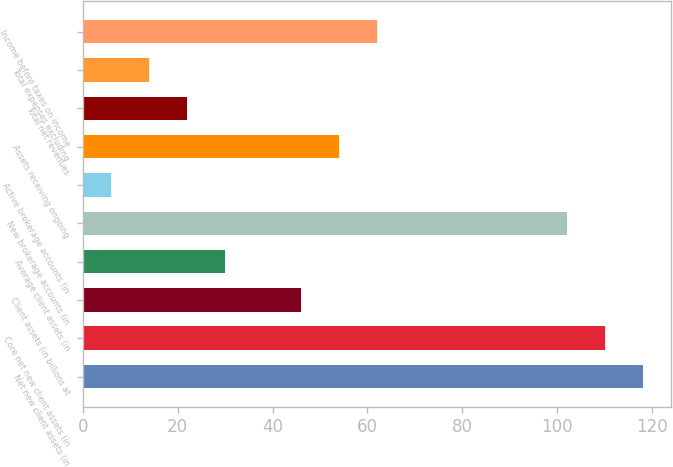<chart> <loc_0><loc_0><loc_500><loc_500><bar_chart><fcel>Net new client assets (in<fcel>Core net new client assets (in<fcel>Client assets (in billions at<fcel>Average client assets (in<fcel>New brokerage accounts (in<fcel>Active brokerage accounts (in<fcel>Assets receiving ongoing<fcel>Total net revenues<fcel>Total expenses excluding<fcel>Income before taxes on income<nl><fcel>118<fcel>110<fcel>46<fcel>30<fcel>102<fcel>6<fcel>54<fcel>22<fcel>14<fcel>62<nl></chart> 